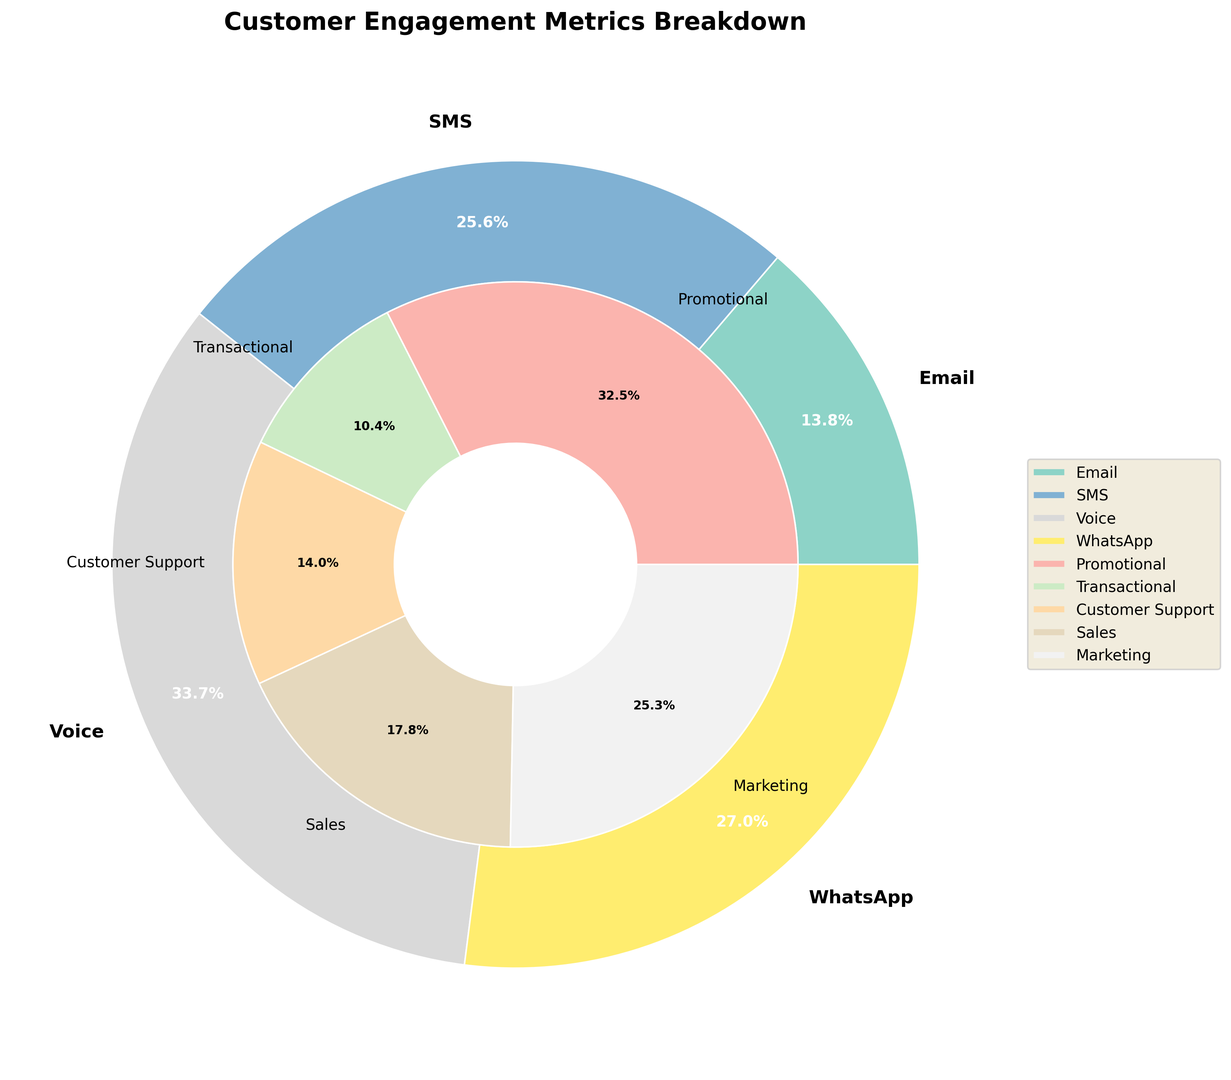What touchpoint has the highest total value? Look at the outer pie chart and identify the segment with the highest percentage. Based on the data, Email has 44.2%, SMS has 54.9%, Voice has 1.8%, and WhatsApp has 29.1%. SMS has the highest total value.
Answer: SMS Which segment within Email has the highest open rate? Look at the nested pie chart focused on Email and identify the segment labeled "Open Rate" with the highest value. Within Email, Promotional Open Rate has 25%, while Transactional Open Rate has 65%.
Answer: Transactional Which has a higher conversion rate, SMS Promotional or Email Promotional? Refer to the values listed in the nested segments for SMS and Email. SMS Promotional has a 5% Conversion Rate while Email Promotional has 3%.
Answer: SMS Promotional How does the customer satisfaction rate for Voice Customer Support compare to WhatsApp Customer Support? Find the customer satisfaction percentages for both Voice and WhatsApp under Customer Support. Voice Customer Support has a satisfaction rate of 85%, while WhatsApp Customer Support has 88%.
Answer: WhatsApp is higher What's the most significant difference in response rates between promotional and transactional segments in SMS? Compare the response rates for SMS Promotional (15%) and SMS Transactional (40%). Calculate the difference: 40% - 15% = 25%
Answer: 25% Which touchpoint has the lowest value contributing to the total? By examining the outer ring of the pie chart, identify the touchpoint with the smallest percentage. Voice has 1.8%, which is the smallest.
Answer: Voice What is the total conversion rate for both promotional and transactional segments in Email? Combine the conversion rates for promotional (3%) and transactional (12%) segments in Email. The total is 3% + 12% = 15%.
Answer: 15% Which segment in WhatsApp has the highest value percentage-wise? Observe the nested segments in WhatsApp. Marketing includes Open Rate (75%), Click-through Rate (25%), and Conversion Rate (8%), while Customer Support includes Response Time (5%), Resolution Rate (80%), and Customer Satisfaction (88%). The highest is Customer Support - Customer Satisfaction which has 88%.
Answer: Customer Support Comparing the values for Open Rate and Click-through Rate in WhatsApp Marketing, which is higher? Within WhatsApp Marketing, compare the Open Rate (75%) and the Click-through Rate (25%). The Open Rate is higher.
Answer: Open Rate What is the overall percentage value difference between Email and WhatsApp touchpoints? Calculate the absolute difference in overall percentages: Email (44.2%) and WhatsApp (29.1%). The difference is 44.2% - 29.1% = 15.1%.
Answer: 15.1% 